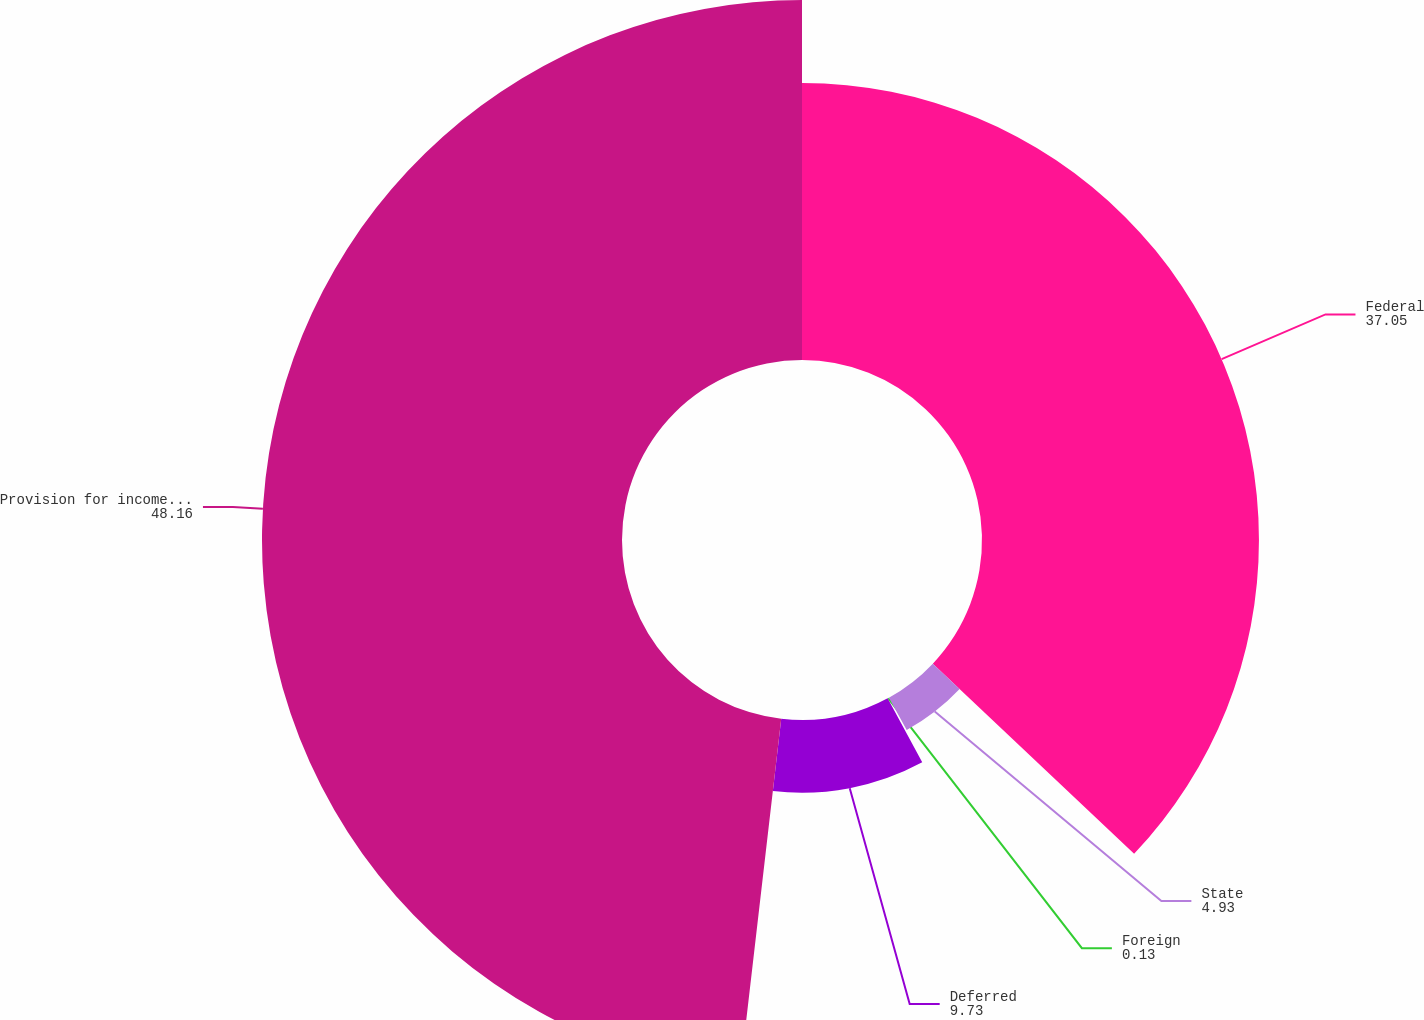<chart> <loc_0><loc_0><loc_500><loc_500><pie_chart><fcel>Federal<fcel>State<fcel>Foreign<fcel>Deferred<fcel>Provision for income taxes<nl><fcel>37.05%<fcel>4.93%<fcel>0.13%<fcel>9.73%<fcel>48.16%<nl></chart> 